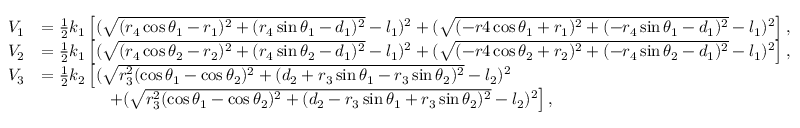Convert formula to latex. <formula><loc_0><loc_0><loc_500><loc_500>\begin{array} { r l } { V _ { 1 } } & { = \frac { 1 } { 2 } k _ { 1 } \left [ ( \sqrt { ( r _ { 4 } \cos \theta _ { 1 } - r _ { 1 } ) ^ { 2 } + ( r _ { 4 } \sin \theta _ { 1 } - d _ { 1 } ) ^ { 2 } } - l _ { 1 } ) ^ { 2 } + ( \sqrt { ( - r 4 \cos \theta _ { 1 } + r _ { 1 } ) ^ { 2 } + ( - r _ { 4 } \sin \theta _ { 1 } - d _ { 1 } ) ^ { 2 } } - l _ { 1 } ) ^ { 2 } \right ] , } \\ { V _ { 2 } } & { = \frac { 1 } { 2 } k _ { 1 } \left [ ( \sqrt { ( r _ { 4 } \cos \theta _ { 2 } - r _ { 2 } ) ^ { 2 } + ( r _ { 4 } \sin \theta _ { 2 } - d _ { 1 } ) ^ { 2 } } - l _ { 1 } ) ^ { 2 } + ( \sqrt { ( - r 4 \cos \theta _ { 2 } + r _ { 2 } ) ^ { 2 } + ( - r _ { 4 } \sin \theta _ { 2 } - d _ { 1 } ) ^ { 2 } } - l _ { 1 } ) ^ { 2 } \right ] , } \\ { V _ { 3 } } & { = \frac { 1 } { 2 } k _ { 2 } \left [ ( \sqrt { r _ { 3 } ^ { 2 } ( \cos \theta _ { 1 } - \cos \theta _ { 2 } ) ^ { 2 } + ( d _ { 2 } + r _ { 3 } \sin \theta _ { 1 } - r _ { 3 } \sin \theta _ { 2 } ) ^ { 2 } } - l _ { 2 } ) ^ { 2 } } \\ & { \quad + ( \sqrt { r _ { 3 } ^ { 2 } ( \cos \theta _ { 1 } - \cos \theta _ { 2 } ) ^ { 2 } + ( d _ { 2 } - r _ { 3 } \sin \theta _ { 1 } + r _ { 3 } \sin \theta _ { 2 } ) ^ { 2 } } - l _ { 2 } ) ^ { 2 } \right ] , } \end{array}</formula> 